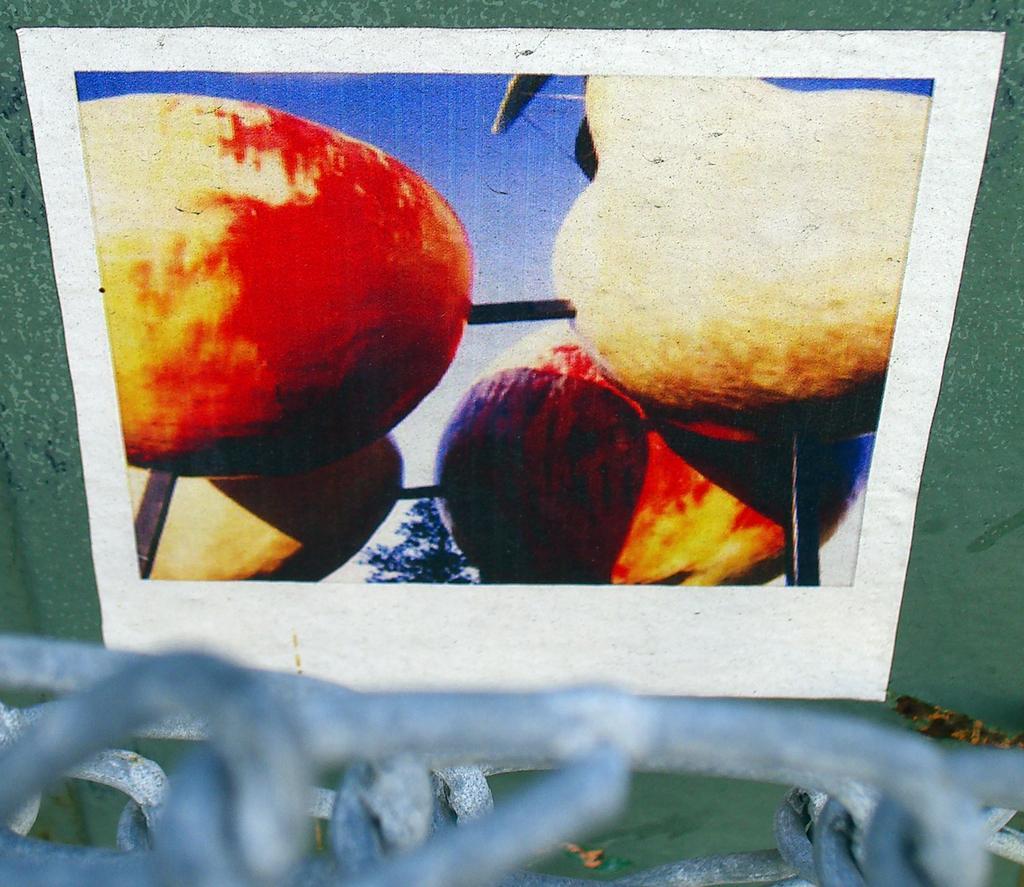Please provide a concise description of this image. In this picture, we can see a poster with some images attached to the wall, and we can see some object in the bottom of the picture. 